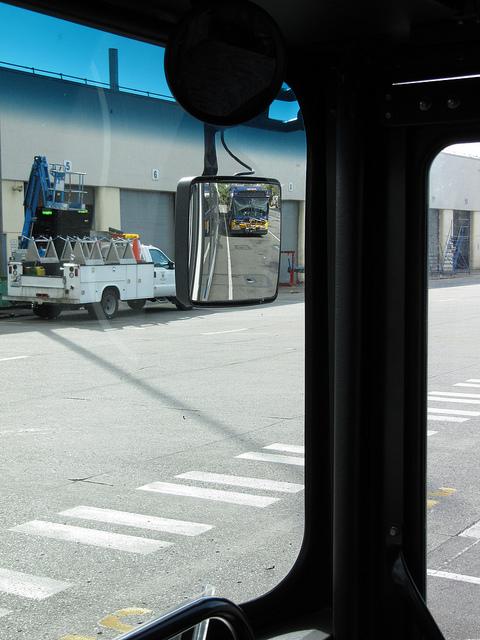What color are the stripes on the pavement?
Quick response, please. White. Was this photo taken from inside a building?
Be succinct. No. Can you see a mirror?
Give a very brief answer. Yes. 